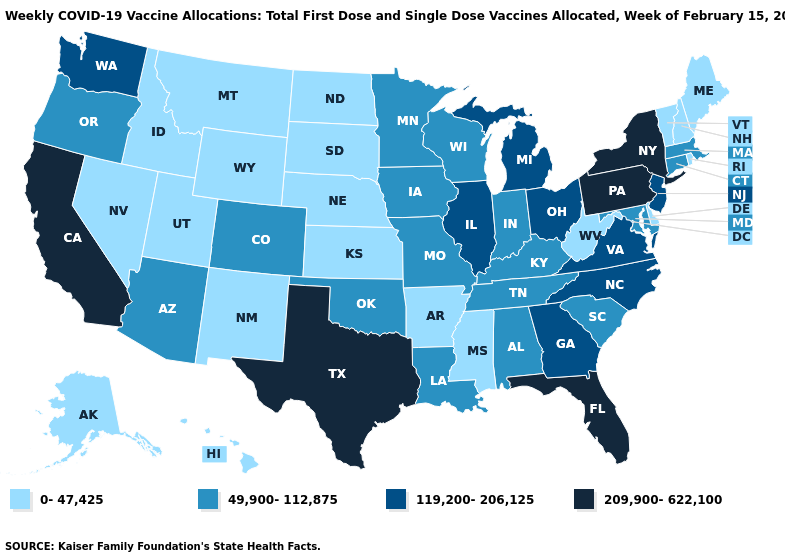Does Michigan have the highest value in the USA?
Concise answer only. No. What is the value of Texas?
Quick response, please. 209,900-622,100. What is the value of Pennsylvania?
Be succinct. 209,900-622,100. Which states have the highest value in the USA?
Answer briefly. California, Florida, New York, Pennsylvania, Texas. Which states have the highest value in the USA?
Give a very brief answer. California, Florida, New York, Pennsylvania, Texas. Among the states that border Georgia , which have the lowest value?
Concise answer only. Alabama, South Carolina, Tennessee. Is the legend a continuous bar?
Write a very short answer. No. What is the value of Minnesota?
Quick response, please. 49,900-112,875. Does Nevada have the lowest value in the USA?
Write a very short answer. Yes. Is the legend a continuous bar?
Concise answer only. No. Among the states that border Kentucky , does Indiana have the highest value?
Give a very brief answer. No. Among the states that border Pennsylvania , which have the lowest value?
Quick response, please. Delaware, West Virginia. What is the value of Alaska?
Concise answer only. 0-47,425. Which states have the lowest value in the West?
Answer briefly. Alaska, Hawaii, Idaho, Montana, Nevada, New Mexico, Utah, Wyoming. Name the states that have a value in the range 119,200-206,125?
Answer briefly. Georgia, Illinois, Michigan, New Jersey, North Carolina, Ohio, Virginia, Washington. 